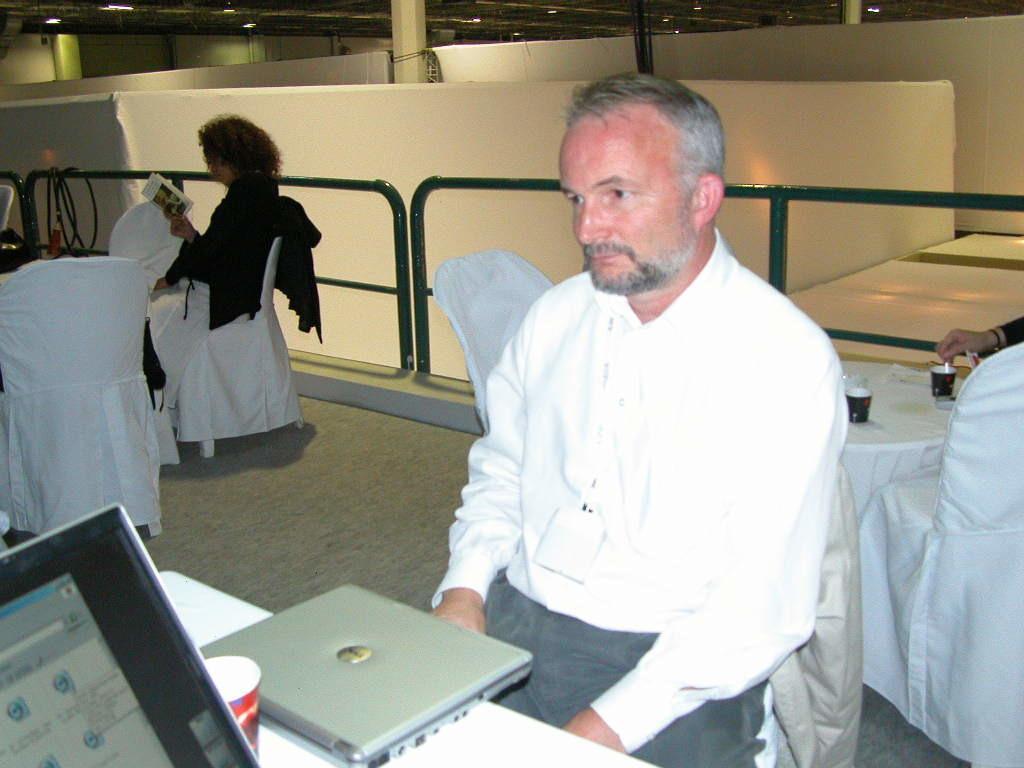Please provide a concise description of this image. In the image we can see a man sitting, wearing clothes and in front of him there is a table. On the table we can see the laptop, glass and the other device. Behind him we can see human hand and two glasses on the table. There are many chairs. Here we can see another person sitting, wearing clothes and holding book in hand. Here we can see floor, metal rod and lights. 